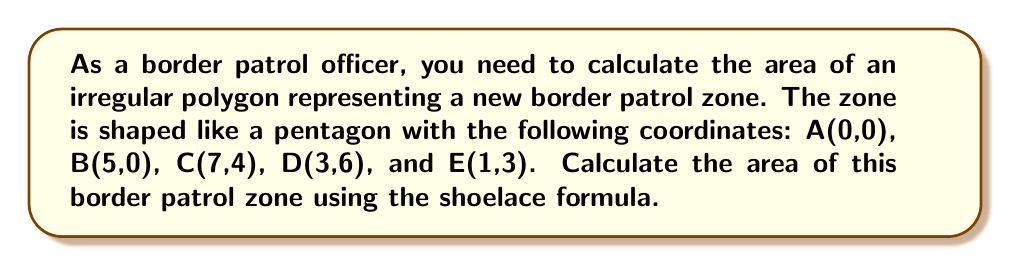Show me your answer to this math problem. To calculate the area of this irregular pentagon, we can use the shoelace formula (also known as the surveyor's formula). The steps are as follows:

1) The shoelace formula for a polygon with vertices $(x_1, y_1), (x_2, y_2), ..., (x_n, y_n)$ is:

   $$Area = \frac{1}{2}|(x_1y_2 + x_2y_3 + ... + x_ny_1) - (y_1x_2 + y_2x_3 + ... + y_nx_1)|$$

2) Let's organize our data:
   A(0,0), B(5,0), C(7,4), D(3,6), E(1,3)

3) Apply the formula:

   $$\begin{align}
   Area &= \frac{1}{2}|(0\cdot0 + 5\cdot4 + 7\cdot6 + 3\cdot3 + 1\cdot0) \\
   &\quad - (0\cdot5 + 0\cdot7 + 4\cdot3 + 6\cdot1 + 3\cdot0)|
   \end{align}$$

4) Simplify:

   $$\begin{align}
   Area &= \frac{1}{2}|(0 + 20 + 42 + 9 + 0) - (0 + 0 + 12 + 6 + 0)| \\
   &= \frac{1}{2}|71 - 18| \\
   &= \frac{1}{2}(53) \\
   &= 26.5
   \end{align}$$

Therefore, the area of the border patrol zone is 26.5 square units.

[asy]
unitsize(1cm);
draw((0,0)--(5,0)--(7,4)--(3,6)--(1,3)--cycle);
label("A(0,0)", (0,0), SW);
label("B(5,0)", (5,0), S);
label("C(7,4)", (7,4), E);
label("D(3,6)", (3,6), N);
label("E(1,3)", (1,3), W);
[/asy]
Answer: The area of the irregular pentagon representing the border patrol zone is 26.5 square units. 